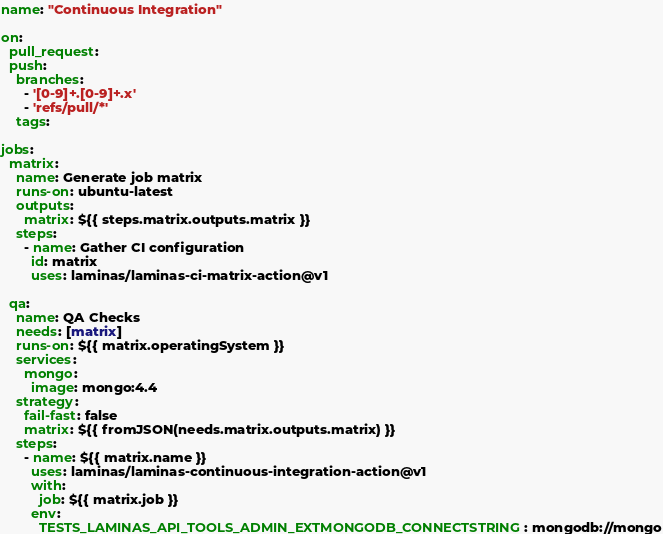Convert code to text. <code><loc_0><loc_0><loc_500><loc_500><_YAML_>name: "Continuous Integration"

on:
  pull_request:
  push:
    branches:
      - '[0-9]+.[0-9]+.x'
      - 'refs/pull/*'
    tags:

jobs:
  matrix:
    name: Generate job matrix
    runs-on: ubuntu-latest
    outputs:
      matrix: ${{ steps.matrix.outputs.matrix }}
    steps:
      - name: Gather CI configuration
        id: matrix
        uses: laminas/laminas-ci-matrix-action@v1

  qa:
    name: QA Checks
    needs: [matrix]
    runs-on: ${{ matrix.operatingSystem }}
    services:
      mongo:
        image: mongo:4.4
    strategy:
      fail-fast: false
      matrix: ${{ fromJSON(needs.matrix.outputs.matrix) }}
    steps:
      - name: ${{ matrix.name }}
        uses: laminas/laminas-continuous-integration-action@v1
        with:
          job: ${{ matrix.job }}
        env:
          TESTS_LAMINAS_API_TOOLS_ADMIN_EXTMONGODB_CONNECTSTRING: mongodb://mongo
</code> 